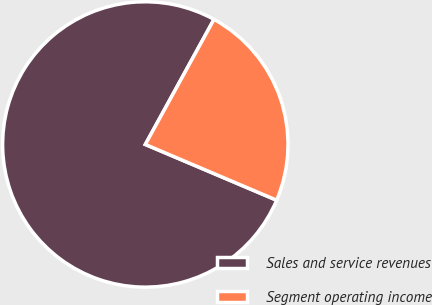Convert chart. <chart><loc_0><loc_0><loc_500><loc_500><pie_chart><fcel>Sales and service revenues<fcel>Segment operating income<nl><fcel>76.6%<fcel>23.4%<nl></chart> 